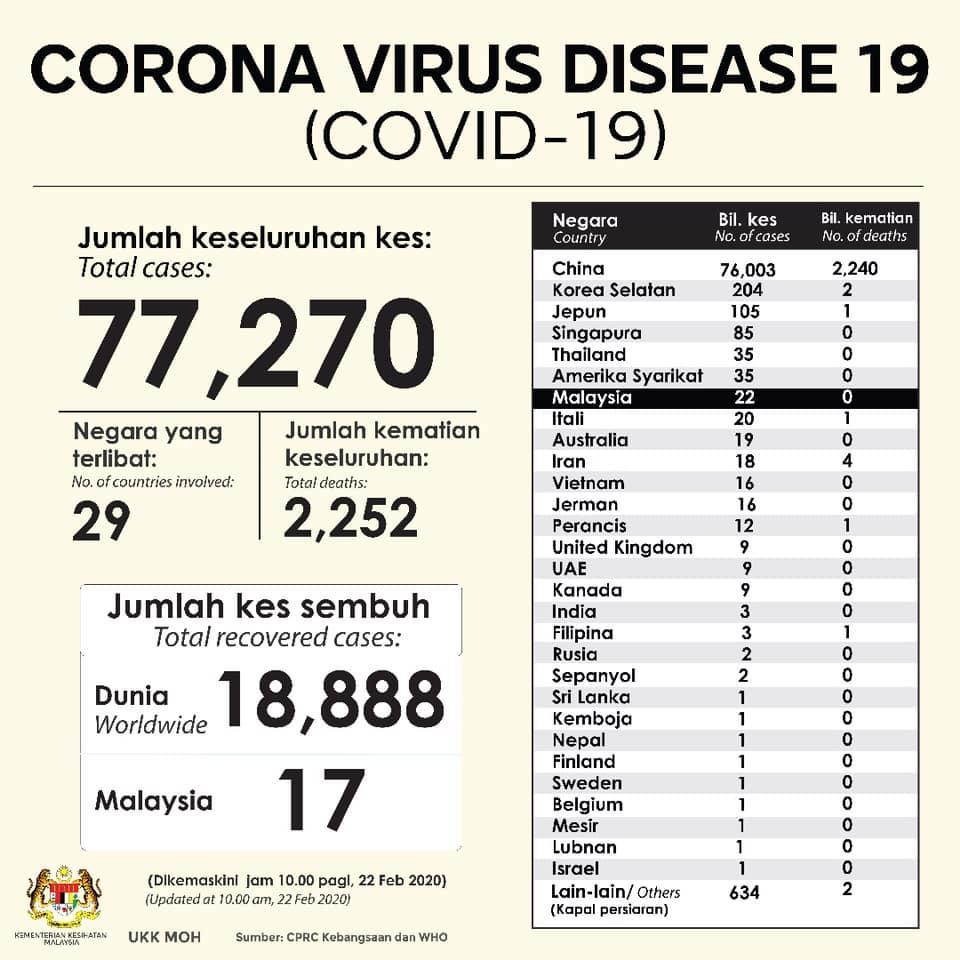What is the difference between the number of cases and number of deaths in Malaysia?
Answer the question with a short phrase. 22 What is the difference between the number of cases and number of deaths in Israel? 1 What is the difference between the number of cases and number of deaths in Iran? 14 In how many countries the number of cases equal to 1? 9 What is the difference between the number of cases and number of deaths in Thailand? 35 